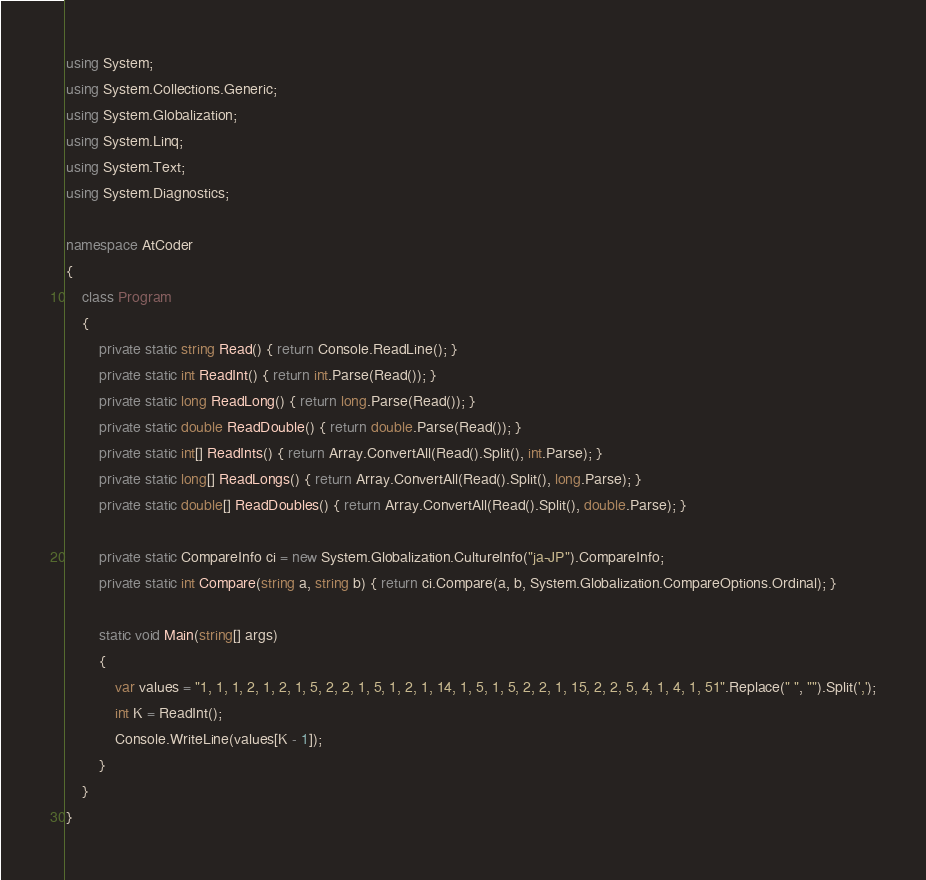<code> <loc_0><loc_0><loc_500><loc_500><_C#_>using System;
using System.Collections.Generic;
using System.Globalization;
using System.Linq;
using System.Text;
using System.Diagnostics;

namespace AtCoder
{
    class Program
    {
        private static string Read() { return Console.ReadLine(); }
        private static int ReadInt() { return int.Parse(Read()); }
        private static long ReadLong() { return long.Parse(Read()); }
        private static double ReadDouble() { return double.Parse(Read()); }
        private static int[] ReadInts() { return Array.ConvertAll(Read().Split(), int.Parse); }
        private static long[] ReadLongs() { return Array.ConvertAll(Read().Split(), long.Parse); }
        private static double[] ReadDoubles() { return Array.ConvertAll(Read().Split(), double.Parse); }

        private static CompareInfo ci = new System.Globalization.CultureInfo("ja-JP").CompareInfo;
        private static int Compare(string a, string b) { return ci.Compare(a, b, System.Globalization.CompareOptions.Ordinal); }

        static void Main(string[] args)
        {
            var values = "1, 1, 1, 2, 1, 2, 1, 5, 2, 2, 1, 5, 1, 2, 1, 14, 1, 5, 1, 5, 2, 2, 1, 15, 2, 2, 5, 4, 1, 4, 1, 51".Replace(" ", "").Split(',');
            int K = ReadInt();
            Console.WriteLine(values[K - 1]);
        }
    }
}
</code> 